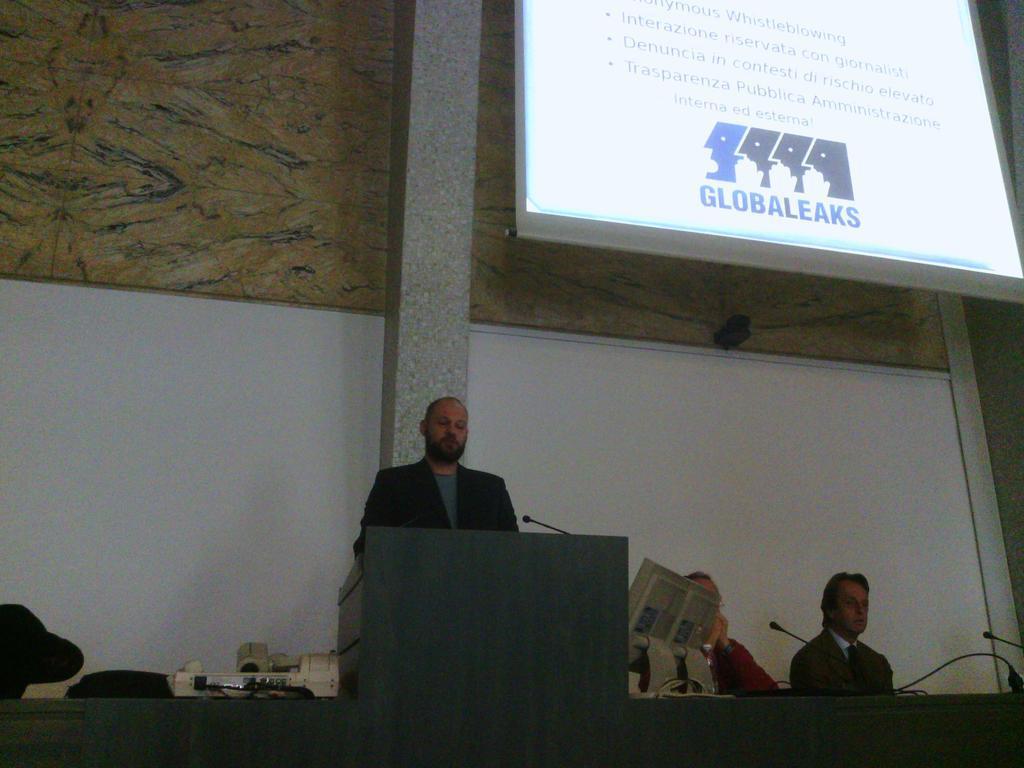How would you summarize this image in a sentence or two? In this image we can see the person standing in front of the podium and there are microphones. And there are a few people sitting on the chair and the object looks like a printer. And at the back we can see the wall and pillar. And there is the screen with text and image. 